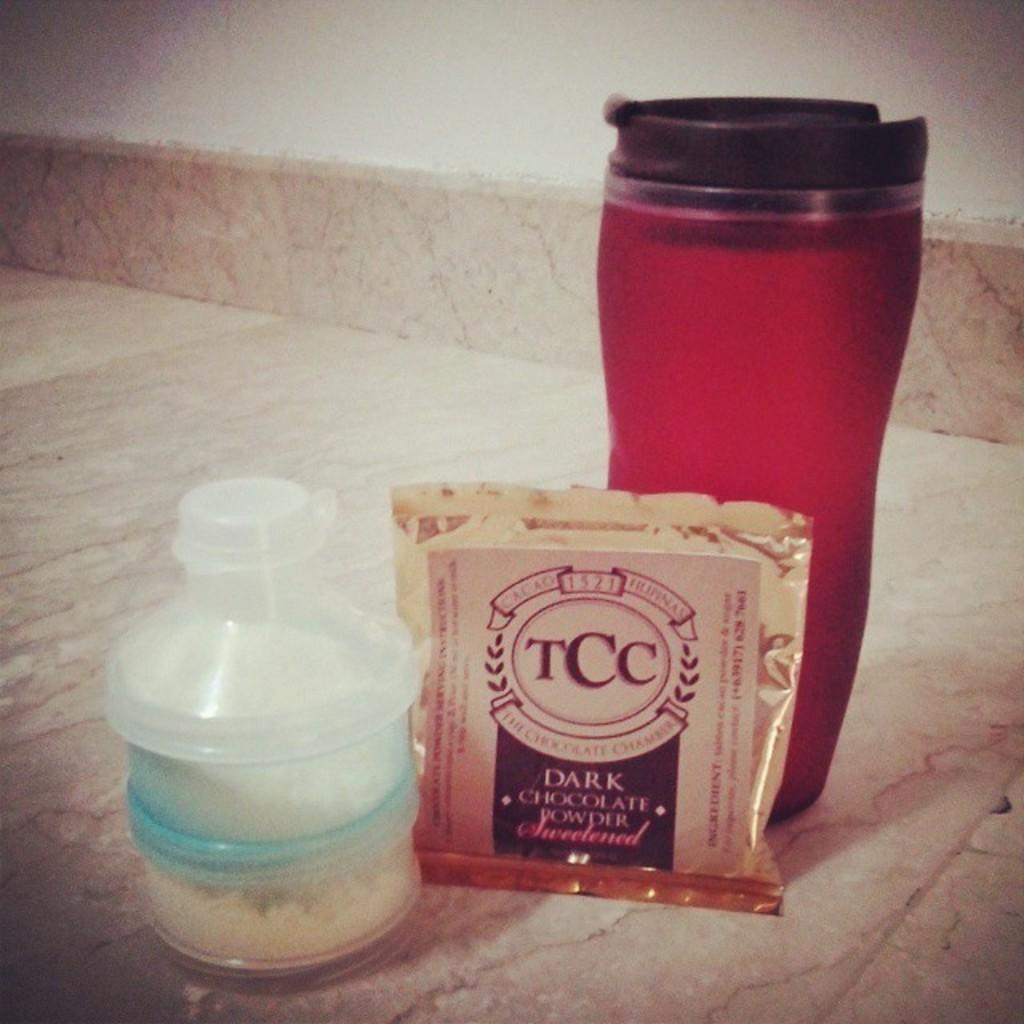<image>
Provide a brief description of the given image. a white bottle, TCC Dark Chocolate Powder pack, and red cup on a marble top 